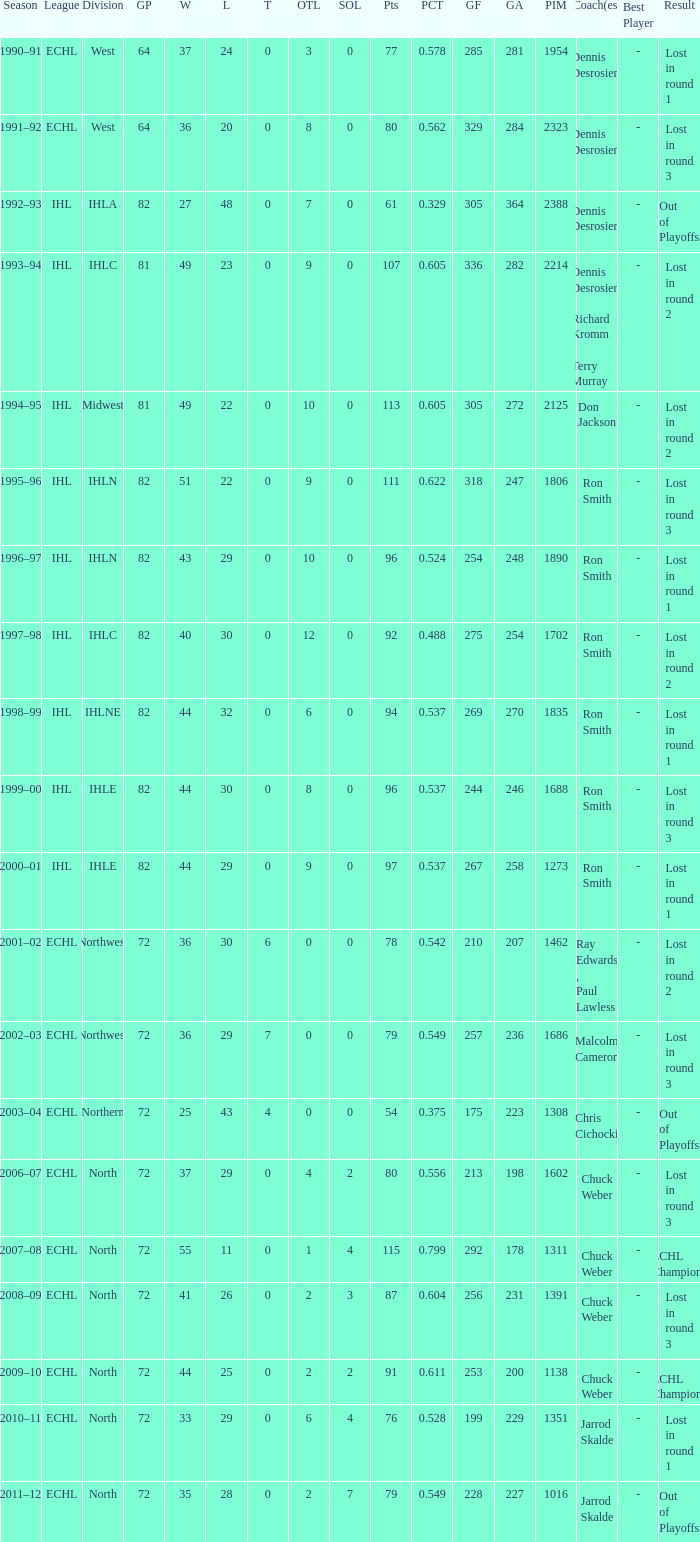What was the maximum OTL if L is 28? 2.0. 